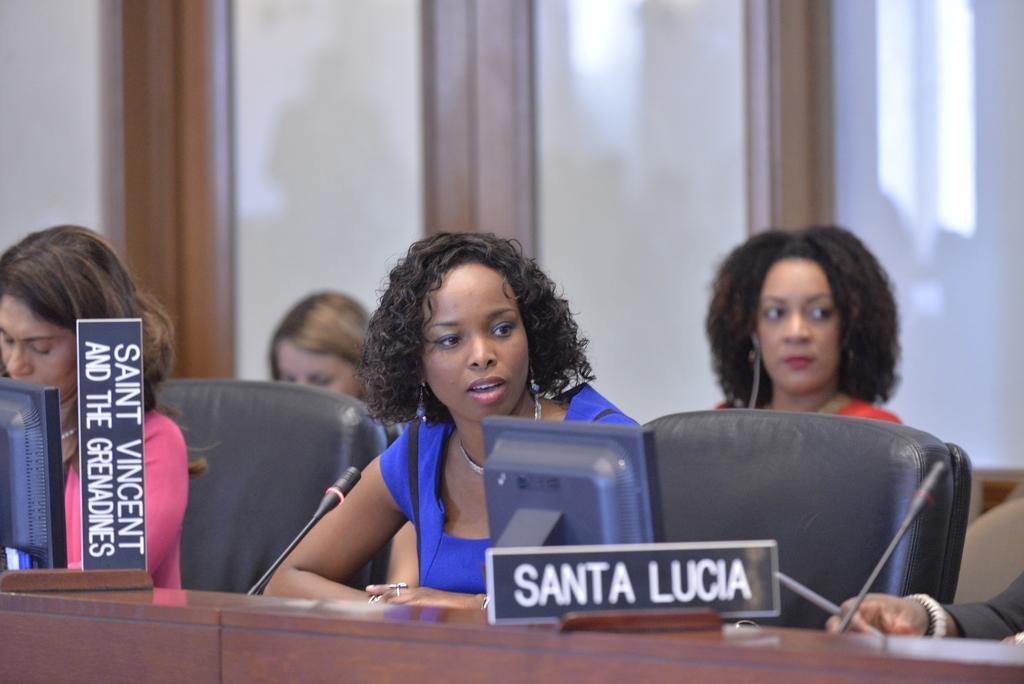In one or two sentences, can you explain what this image depicts? As we can see in the image there are group of people sitting on chairs and there is a table. On table there are mice and screen. 